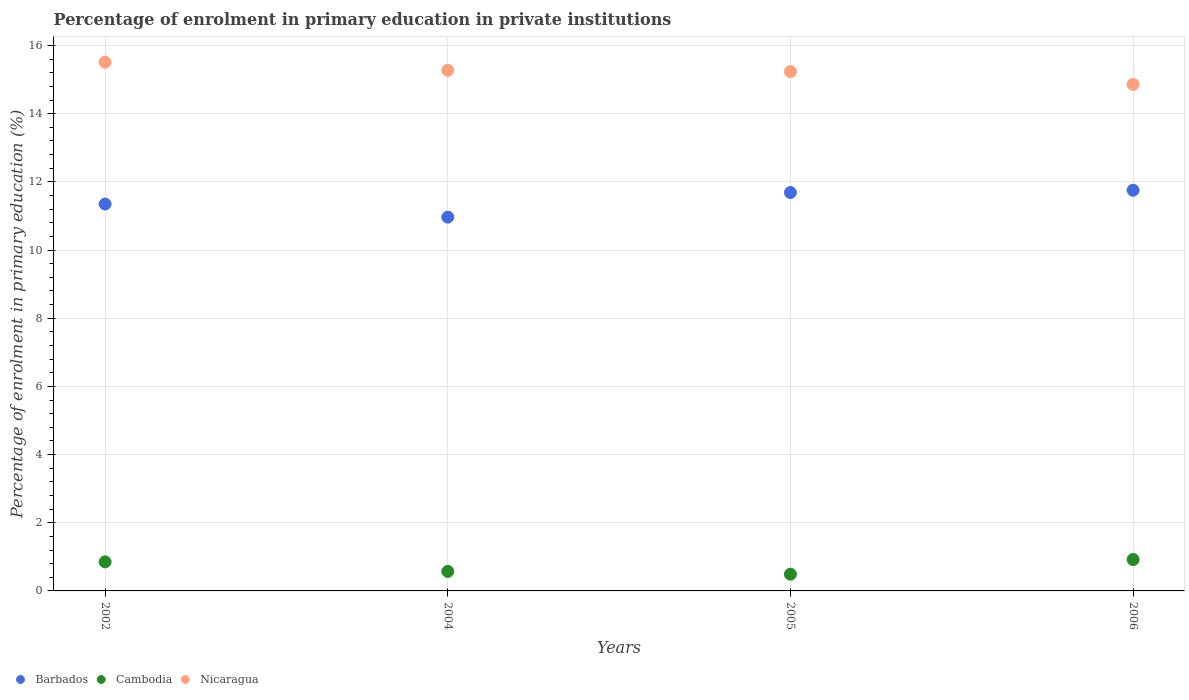How many different coloured dotlines are there?
Make the answer very short. 3. Is the number of dotlines equal to the number of legend labels?
Provide a succinct answer. Yes. What is the percentage of enrolment in primary education in Cambodia in 2002?
Give a very brief answer. 0.85. Across all years, what is the maximum percentage of enrolment in primary education in Barbados?
Keep it short and to the point. 11.75. Across all years, what is the minimum percentage of enrolment in primary education in Cambodia?
Provide a succinct answer. 0.49. In which year was the percentage of enrolment in primary education in Nicaragua maximum?
Offer a very short reply. 2002. What is the total percentage of enrolment in primary education in Cambodia in the graph?
Your answer should be compact. 2.84. What is the difference between the percentage of enrolment in primary education in Cambodia in 2005 and that in 2006?
Your answer should be compact. -0.43. What is the difference between the percentage of enrolment in primary education in Barbados in 2002 and the percentage of enrolment in primary education in Cambodia in 2005?
Offer a terse response. 10.86. What is the average percentage of enrolment in primary education in Cambodia per year?
Give a very brief answer. 0.71. In the year 2005, what is the difference between the percentage of enrolment in primary education in Nicaragua and percentage of enrolment in primary education in Cambodia?
Offer a terse response. 14.74. What is the ratio of the percentage of enrolment in primary education in Barbados in 2004 to that in 2005?
Your response must be concise. 0.94. What is the difference between the highest and the second highest percentage of enrolment in primary education in Cambodia?
Give a very brief answer. 0.07. What is the difference between the highest and the lowest percentage of enrolment in primary education in Nicaragua?
Your answer should be compact. 0.65. Is it the case that in every year, the sum of the percentage of enrolment in primary education in Cambodia and percentage of enrolment in primary education in Nicaragua  is greater than the percentage of enrolment in primary education in Barbados?
Keep it short and to the point. Yes. How many dotlines are there?
Ensure brevity in your answer.  3. How many years are there in the graph?
Provide a short and direct response. 4. What is the difference between two consecutive major ticks on the Y-axis?
Your response must be concise. 2. Does the graph contain any zero values?
Give a very brief answer. No. How are the legend labels stacked?
Provide a succinct answer. Horizontal. What is the title of the graph?
Provide a succinct answer. Percentage of enrolment in primary education in private institutions. Does "Dominican Republic" appear as one of the legend labels in the graph?
Your response must be concise. No. What is the label or title of the X-axis?
Ensure brevity in your answer.  Years. What is the label or title of the Y-axis?
Make the answer very short. Percentage of enrolment in primary education (%). What is the Percentage of enrolment in primary education (%) of Barbados in 2002?
Offer a terse response. 11.35. What is the Percentage of enrolment in primary education (%) of Cambodia in 2002?
Offer a terse response. 0.85. What is the Percentage of enrolment in primary education (%) in Nicaragua in 2002?
Ensure brevity in your answer.  15.51. What is the Percentage of enrolment in primary education (%) in Barbados in 2004?
Ensure brevity in your answer.  10.96. What is the Percentage of enrolment in primary education (%) of Cambodia in 2004?
Make the answer very short. 0.57. What is the Percentage of enrolment in primary education (%) of Nicaragua in 2004?
Provide a succinct answer. 15.27. What is the Percentage of enrolment in primary education (%) in Barbados in 2005?
Give a very brief answer. 11.69. What is the Percentage of enrolment in primary education (%) of Cambodia in 2005?
Offer a terse response. 0.49. What is the Percentage of enrolment in primary education (%) in Nicaragua in 2005?
Ensure brevity in your answer.  15.23. What is the Percentage of enrolment in primary education (%) of Barbados in 2006?
Offer a terse response. 11.75. What is the Percentage of enrolment in primary education (%) in Cambodia in 2006?
Keep it short and to the point. 0.92. What is the Percentage of enrolment in primary education (%) in Nicaragua in 2006?
Your answer should be compact. 14.86. Across all years, what is the maximum Percentage of enrolment in primary education (%) of Barbados?
Your answer should be very brief. 11.75. Across all years, what is the maximum Percentage of enrolment in primary education (%) of Cambodia?
Make the answer very short. 0.92. Across all years, what is the maximum Percentage of enrolment in primary education (%) in Nicaragua?
Give a very brief answer. 15.51. Across all years, what is the minimum Percentage of enrolment in primary education (%) in Barbados?
Your answer should be very brief. 10.96. Across all years, what is the minimum Percentage of enrolment in primary education (%) of Cambodia?
Ensure brevity in your answer.  0.49. Across all years, what is the minimum Percentage of enrolment in primary education (%) of Nicaragua?
Give a very brief answer. 14.86. What is the total Percentage of enrolment in primary education (%) of Barbados in the graph?
Provide a succinct answer. 45.75. What is the total Percentage of enrolment in primary education (%) of Cambodia in the graph?
Give a very brief answer. 2.84. What is the total Percentage of enrolment in primary education (%) in Nicaragua in the graph?
Provide a succinct answer. 60.87. What is the difference between the Percentage of enrolment in primary education (%) of Barbados in 2002 and that in 2004?
Your answer should be compact. 0.38. What is the difference between the Percentage of enrolment in primary education (%) in Cambodia in 2002 and that in 2004?
Your answer should be very brief. 0.28. What is the difference between the Percentage of enrolment in primary education (%) of Nicaragua in 2002 and that in 2004?
Provide a succinct answer. 0.24. What is the difference between the Percentage of enrolment in primary education (%) in Barbados in 2002 and that in 2005?
Provide a short and direct response. -0.34. What is the difference between the Percentage of enrolment in primary education (%) in Cambodia in 2002 and that in 2005?
Offer a terse response. 0.36. What is the difference between the Percentage of enrolment in primary education (%) of Nicaragua in 2002 and that in 2005?
Make the answer very short. 0.28. What is the difference between the Percentage of enrolment in primary education (%) in Barbados in 2002 and that in 2006?
Offer a very short reply. -0.4. What is the difference between the Percentage of enrolment in primary education (%) of Cambodia in 2002 and that in 2006?
Give a very brief answer. -0.07. What is the difference between the Percentage of enrolment in primary education (%) of Nicaragua in 2002 and that in 2006?
Ensure brevity in your answer.  0.65. What is the difference between the Percentage of enrolment in primary education (%) in Barbados in 2004 and that in 2005?
Your response must be concise. -0.72. What is the difference between the Percentage of enrolment in primary education (%) in Cambodia in 2004 and that in 2005?
Ensure brevity in your answer.  0.08. What is the difference between the Percentage of enrolment in primary education (%) in Nicaragua in 2004 and that in 2005?
Offer a terse response. 0.04. What is the difference between the Percentage of enrolment in primary education (%) of Barbados in 2004 and that in 2006?
Your response must be concise. -0.79. What is the difference between the Percentage of enrolment in primary education (%) of Cambodia in 2004 and that in 2006?
Ensure brevity in your answer.  -0.35. What is the difference between the Percentage of enrolment in primary education (%) of Nicaragua in 2004 and that in 2006?
Offer a terse response. 0.41. What is the difference between the Percentage of enrolment in primary education (%) in Barbados in 2005 and that in 2006?
Give a very brief answer. -0.07. What is the difference between the Percentage of enrolment in primary education (%) in Cambodia in 2005 and that in 2006?
Offer a very short reply. -0.43. What is the difference between the Percentage of enrolment in primary education (%) in Nicaragua in 2005 and that in 2006?
Your answer should be compact. 0.37. What is the difference between the Percentage of enrolment in primary education (%) of Barbados in 2002 and the Percentage of enrolment in primary education (%) of Cambodia in 2004?
Provide a short and direct response. 10.78. What is the difference between the Percentage of enrolment in primary education (%) of Barbados in 2002 and the Percentage of enrolment in primary education (%) of Nicaragua in 2004?
Provide a short and direct response. -3.92. What is the difference between the Percentage of enrolment in primary education (%) in Cambodia in 2002 and the Percentage of enrolment in primary education (%) in Nicaragua in 2004?
Offer a very short reply. -14.42. What is the difference between the Percentage of enrolment in primary education (%) in Barbados in 2002 and the Percentage of enrolment in primary education (%) in Cambodia in 2005?
Provide a succinct answer. 10.86. What is the difference between the Percentage of enrolment in primary education (%) in Barbados in 2002 and the Percentage of enrolment in primary education (%) in Nicaragua in 2005?
Your answer should be compact. -3.88. What is the difference between the Percentage of enrolment in primary education (%) of Cambodia in 2002 and the Percentage of enrolment in primary education (%) of Nicaragua in 2005?
Provide a short and direct response. -14.38. What is the difference between the Percentage of enrolment in primary education (%) in Barbados in 2002 and the Percentage of enrolment in primary education (%) in Cambodia in 2006?
Your answer should be very brief. 10.43. What is the difference between the Percentage of enrolment in primary education (%) in Barbados in 2002 and the Percentage of enrolment in primary education (%) in Nicaragua in 2006?
Make the answer very short. -3.51. What is the difference between the Percentage of enrolment in primary education (%) in Cambodia in 2002 and the Percentage of enrolment in primary education (%) in Nicaragua in 2006?
Provide a succinct answer. -14.01. What is the difference between the Percentage of enrolment in primary education (%) of Barbados in 2004 and the Percentage of enrolment in primary education (%) of Cambodia in 2005?
Ensure brevity in your answer.  10.47. What is the difference between the Percentage of enrolment in primary education (%) in Barbados in 2004 and the Percentage of enrolment in primary education (%) in Nicaragua in 2005?
Offer a very short reply. -4.27. What is the difference between the Percentage of enrolment in primary education (%) in Cambodia in 2004 and the Percentage of enrolment in primary education (%) in Nicaragua in 2005?
Keep it short and to the point. -14.66. What is the difference between the Percentage of enrolment in primary education (%) of Barbados in 2004 and the Percentage of enrolment in primary education (%) of Cambodia in 2006?
Offer a very short reply. 10.04. What is the difference between the Percentage of enrolment in primary education (%) of Barbados in 2004 and the Percentage of enrolment in primary education (%) of Nicaragua in 2006?
Make the answer very short. -3.89. What is the difference between the Percentage of enrolment in primary education (%) in Cambodia in 2004 and the Percentage of enrolment in primary education (%) in Nicaragua in 2006?
Offer a terse response. -14.29. What is the difference between the Percentage of enrolment in primary education (%) of Barbados in 2005 and the Percentage of enrolment in primary education (%) of Cambodia in 2006?
Make the answer very short. 10.76. What is the difference between the Percentage of enrolment in primary education (%) of Barbados in 2005 and the Percentage of enrolment in primary education (%) of Nicaragua in 2006?
Offer a very short reply. -3.17. What is the difference between the Percentage of enrolment in primary education (%) in Cambodia in 2005 and the Percentage of enrolment in primary education (%) in Nicaragua in 2006?
Your answer should be compact. -14.37. What is the average Percentage of enrolment in primary education (%) in Barbados per year?
Provide a succinct answer. 11.44. What is the average Percentage of enrolment in primary education (%) in Cambodia per year?
Make the answer very short. 0.71. What is the average Percentage of enrolment in primary education (%) of Nicaragua per year?
Offer a terse response. 15.22. In the year 2002, what is the difference between the Percentage of enrolment in primary education (%) in Barbados and Percentage of enrolment in primary education (%) in Cambodia?
Give a very brief answer. 10.5. In the year 2002, what is the difference between the Percentage of enrolment in primary education (%) of Barbados and Percentage of enrolment in primary education (%) of Nicaragua?
Provide a succinct answer. -4.16. In the year 2002, what is the difference between the Percentage of enrolment in primary education (%) of Cambodia and Percentage of enrolment in primary education (%) of Nicaragua?
Ensure brevity in your answer.  -14.66. In the year 2004, what is the difference between the Percentage of enrolment in primary education (%) of Barbados and Percentage of enrolment in primary education (%) of Cambodia?
Ensure brevity in your answer.  10.39. In the year 2004, what is the difference between the Percentage of enrolment in primary education (%) of Barbados and Percentage of enrolment in primary education (%) of Nicaragua?
Provide a short and direct response. -4.31. In the year 2004, what is the difference between the Percentage of enrolment in primary education (%) of Cambodia and Percentage of enrolment in primary education (%) of Nicaragua?
Make the answer very short. -14.7. In the year 2005, what is the difference between the Percentage of enrolment in primary education (%) in Barbados and Percentage of enrolment in primary education (%) in Cambodia?
Offer a terse response. 11.19. In the year 2005, what is the difference between the Percentage of enrolment in primary education (%) in Barbados and Percentage of enrolment in primary education (%) in Nicaragua?
Give a very brief answer. -3.55. In the year 2005, what is the difference between the Percentage of enrolment in primary education (%) in Cambodia and Percentage of enrolment in primary education (%) in Nicaragua?
Your answer should be compact. -14.74. In the year 2006, what is the difference between the Percentage of enrolment in primary education (%) of Barbados and Percentage of enrolment in primary education (%) of Cambodia?
Make the answer very short. 10.83. In the year 2006, what is the difference between the Percentage of enrolment in primary education (%) of Barbados and Percentage of enrolment in primary education (%) of Nicaragua?
Give a very brief answer. -3.1. In the year 2006, what is the difference between the Percentage of enrolment in primary education (%) of Cambodia and Percentage of enrolment in primary education (%) of Nicaragua?
Offer a very short reply. -13.94. What is the ratio of the Percentage of enrolment in primary education (%) in Barbados in 2002 to that in 2004?
Provide a short and direct response. 1.04. What is the ratio of the Percentage of enrolment in primary education (%) of Cambodia in 2002 to that in 2004?
Ensure brevity in your answer.  1.49. What is the ratio of the Percentage of enrolment in primary education (%) in Nicaragua in 2002 to that in 2004?
Ensure brevity in your answer.  1.02. What is the ratio of the Percentage of enrolment in primary education (%) in Barbados in 2002 to that in 2005?
Make the answer very short. 0.97. What is the ratio of the Percentage of enrolment in primary education (%) of Cambodia in 2002 to that in 2005?
Make the answer very short. 1.73. What is the ratio of the Percentage of enrolment in primary education (%) of Nicaragua in 2002 to that in 2005?
Provide a short and direct response. 1.02. What is the ratio of the Percentage of enrolment in primary education (%) of Barbados in 2002 to that in 2006?
Provide a succinct answer. 0.97. What is the ratio of the Percentage of enrolment in primary education (%) of Cambodia in 2002 to that in 2006?
Your answer should be very brief. 0.92. What is the ratio of the Percentage of enrolment in primary education (%) in Nicaragua in 2002 to that in 2006?
Keep it short and to the point. 1.04. What is the ratio of the Percentage of enrolment in primary education (%) of Barbados in 2004 to that in 2005?
Your answer should be very brief. 0.94. What is the ratio of the Percentage of enrolment in primary education (%) in Cambodia in 2004 to that in 2005?
Offer a very short reply. 1.16. What is the ratio of the Percentage of enrolment in primary education (%) in Nicaragua in 2004 to that in 2005?
Provide a succinct answer. 1. What is the ratio of the Percentage of enrolment in primary education (%) in Barbados in 2004 to that in 2006?
Provide a short and direct response. 0.93. What is the ratio of the Percentage of enrolment in primary education (%) in Cambodia in 2004 to that in 2006?
Provide a succinct answer. 0.62. What is the ratio of the Percentage of enrolment in primary education (%) of Nicaragua in 2004 to that in 2006?
Provide a short and direct response. 1.03. What is the ratio of the Percentage of enrolment in primary education (%) in Cambodia in 2005 to that in 2006?
Your answer should be compact. 0.53. What is the ratio of the Percentage of enrolment in primary education (%) in Nicaragua in 2005 to that in 2006?
Your response must be concise. 1.03. What is the difference between the highest and the second highest Percentage of enrolment in primary education (%) of Barbados?
Your answer should be very brief. 0.07. What is the difference between the highest and the second highest Percentage of enrolment in primary education (%) of Cambodia?
Provide a succinct answer. 0.07. What is the difference between the highest and the second highest Percentage of enrolment in primary education (%) in Nicaragua?
Provide a short and direct response. 0.24. What is the difference between the highest and the lowest Percentage of enrolment in primary education (%) of Barbados?
Your response must be concise. 0.79. What is the difference between the highest and the lowest Percentage of enrolment in primary education (%) of Cambodia?
Your response must be concise. 0.43. What is the difference between the highest and the lowest Percentage of enrolment in primary education (%) of Nicaragua?
Make the answer very short. 0.65. 